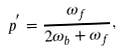<formula> <loc_0><loc_0><loc_500><loc_500>p ^ { ^ { \prime } } = \frac { \omega _ { f } } { 2 \omega _ { b } + \omega _ { f } } ,</formula> 